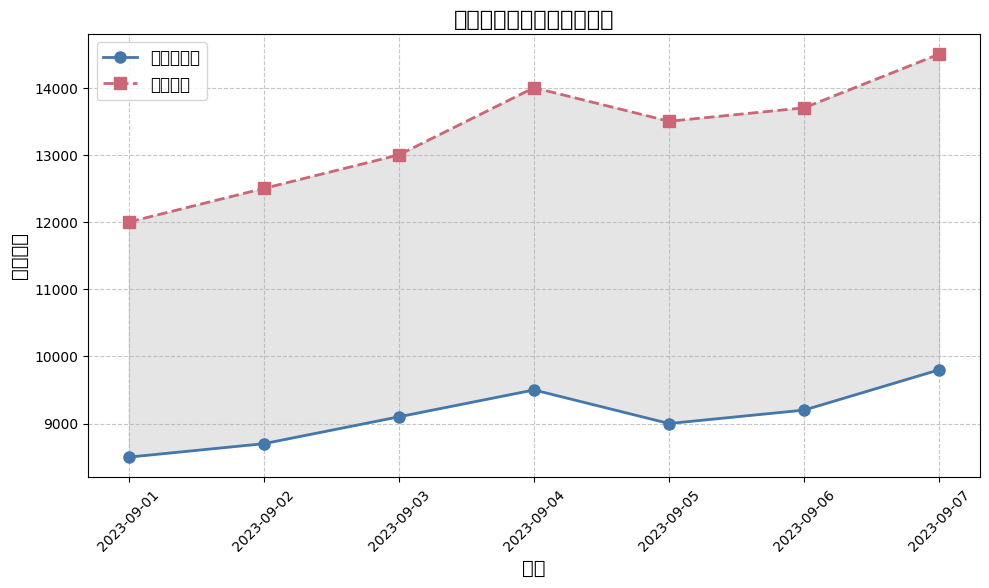玩家活跃度在一周内的变化中，哪一天的日活跃用户最高？ 通过观察图表，我们可以看到9月7日的日活跃用户数量最高，为9800。
Answer: 9月7日 哪一天的峰值用户增长最多？ 从9月1日到9月7日，我们可以观察到用户数量的变化。在9月3日到9月4日的峰值用户增加了最多，从13000增加到14000，增长了1000。
Answer: 9月3日到9月4日 哪一天日活跃用户和峰值用户的差距最大？ 通过填充区域，我们可以比较每天的两个数据。在9月7日，这种差距最大，日活跃用户为9800，峰值用户为14500，差距为4700。
Answer: 9月7日 一周内日活跃用户平均数是多少？ 首先，将所有日活跃用户数量相加 (8500 + 8700 + 9100 + 9500 + 9000 + 9200 + 9800 = 63800)，然后除以天数7，得到平均值63800/7 ≈ 9114.29。
Answer: 9114.29 在本周内，玩家活跃度最平稳的是哪两天？ 观察图表，可以看到9月5日到9月6日期间，日活跃用户和峰值用户的数值变化最小，分别为9000到9200和13500到13700。
Answer: 9月5日到9月6日 本周的日活跃用户量在第几天首次超过9000？ 从图中，可以看到在9月3日，日活跃用户首次超过9000，具体数值为9100。
Answer: 9月3日 从9月1日到9月7日，峰值用户每一天的变化趋势是怎样的？ 按时间顺序观察图表，可以看到峰值用户数量逐渐上升：9月1日12000，9月2日12500，9月3日13000，9月4日14000，9月5日13500，9月6日13700，9月7日14500。
Answer: 逐渐上升 日活跃用户在9月6日比9月2日多多少？ 9月6日的日活跃用户为9200，9月2日为8700，计算差值为9200–8700=500。
Answer: 500 相比于日活跃用户，哪条线用什么颜色代表峰值用户？ 峰值用户的线在图表中用红色的虚线表示，而日活跃用户用蓝色实线表示。
Answer: 红色虚线 